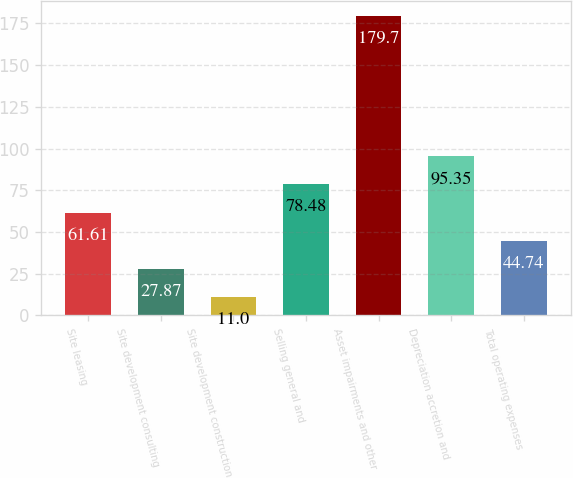Convert chart to OTSL. <chart><loc_0><loc_0><loc_500><loc_500><bar_chart><fcel>Site leasing<fcel>Site development consulting<fcel>Site development construction<fcel>Selling general and<fcel>Asset impairments and other<fcel>Depreciation accretion and<fcel>Total operating expenses<nl><fcel>61.61<fcel>27.87<fcel>11<fcel>78.48<fcel>179.7<fcel>95.35<fcel>44.74<nl></chart> 